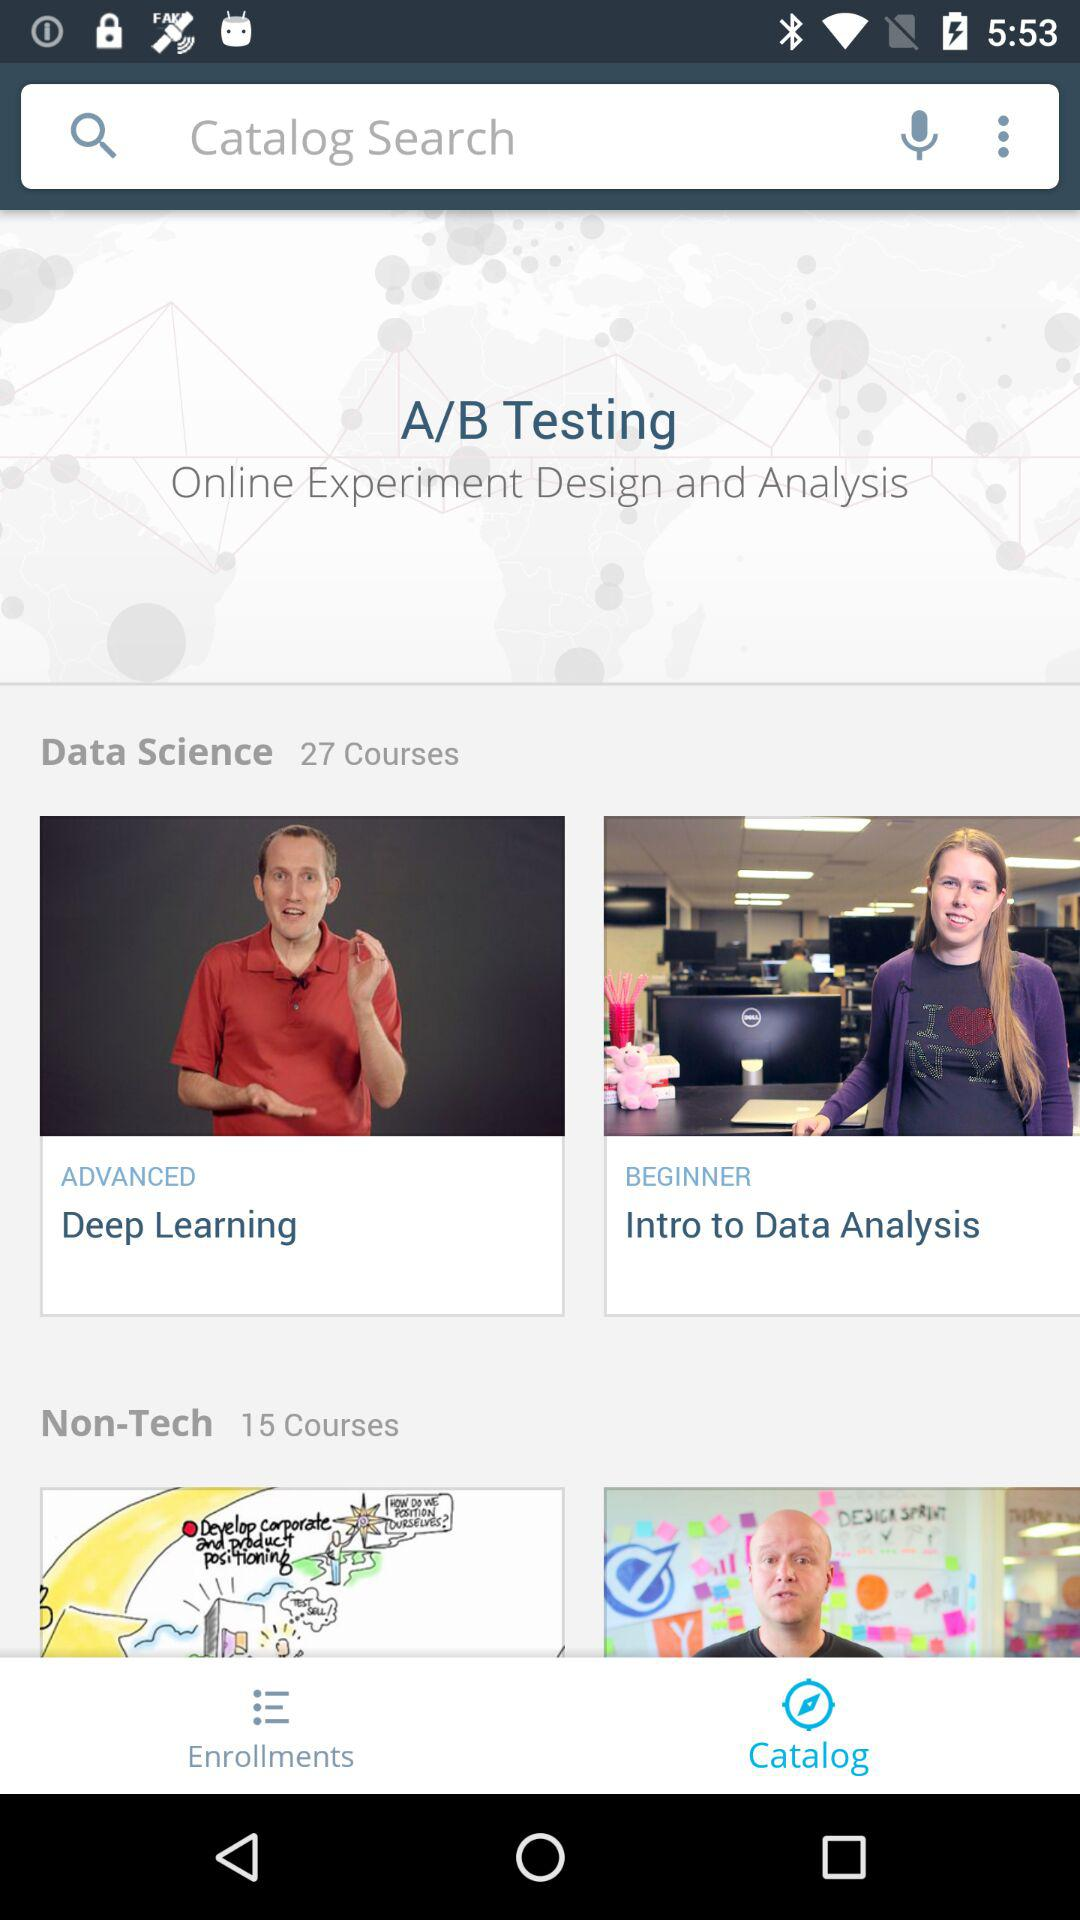What is the total number of "Data Science" courses? The total number of "Data Science" courses is 27. 